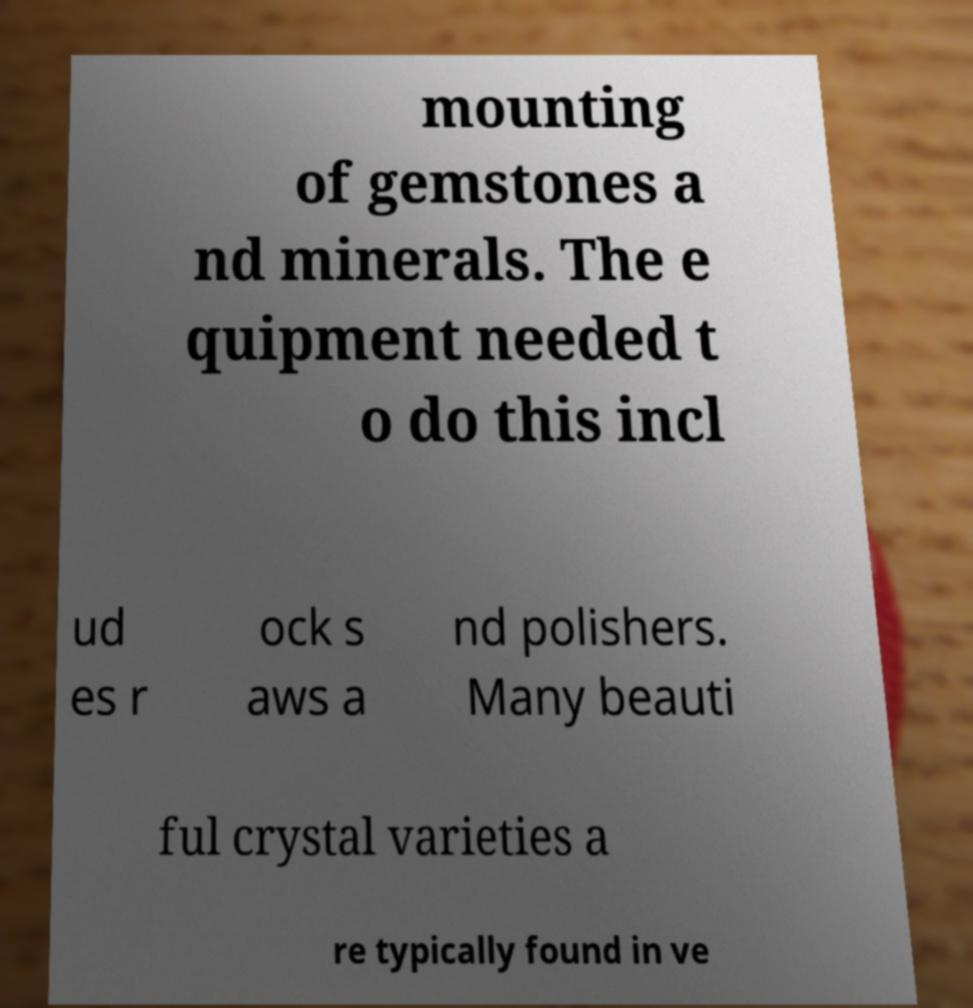Could you extract and type out the text from this image? mounting of gemstones a nd minerals. The e quipment needed t o do this incl ud es r ock s aws a nd polishers. Many beauti ful crystal varieties a re typically found in ve 